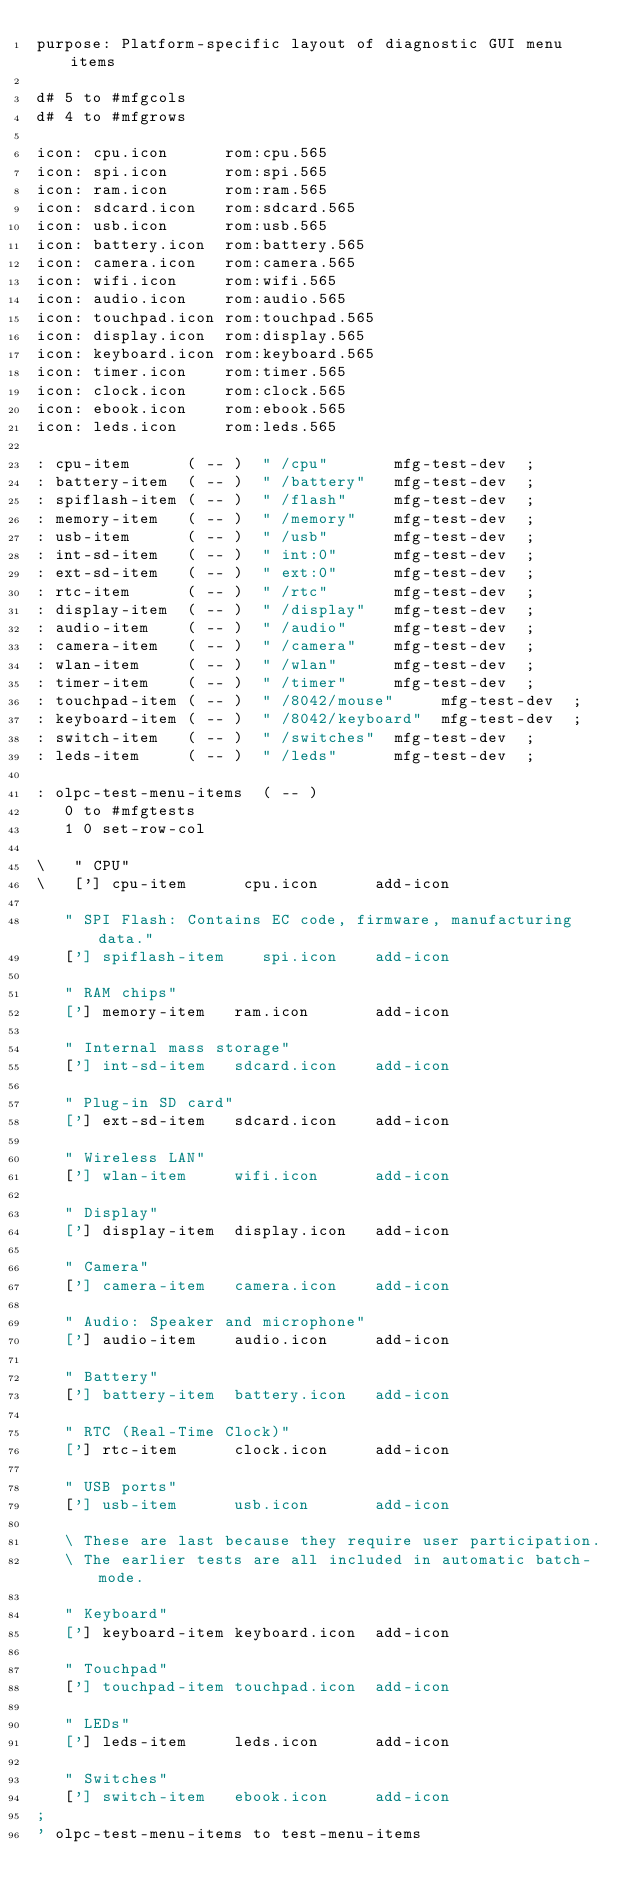<code> <loc_0><loc_0><loc_500><loc_500><_Forth_>purpose: Platform-specific layout of diagnostic GUI menu items

d# 5 to #mfgcols
d# 4 to #mfgrows

icon: cpu.icon      rom:cpu.565
icon: spi.icon      rom:spi.565
icon: ram.icon      rom:ram.565
icon: sdcard.icon   rom:sdcard.565
icon: usb.icon      rom:usb.565
icon: battery.icon  rom:battery.565
icon: camera.icon   rom:camera.565
icon: wifi.icon     rom:wifi.565
icon: audio.icon    rom:audio.565
icon: touchpad.icon rom:touchpad.565
icon: display.icon  rom:display.565
icon: keyboard.icon rom:keyboard.565
icon: timer.icon    rom:timer.565
icon: clock.icon    rom:clock.565
icon: ebook.icon    rom:ebook.565
icon: leds.icon     rom:leds.565

: cpu-item      ( -- )  " /cpu"       mfg-test-dev  ;
: battery-item  ( -- )  " /battery"   mfg-test-dev  ;
: spiflash-item ( -- )  " /flash"     mfg-test-dev  ;
: memory-item   ( -- )  " /memory"    mfg-test-dev  ;
: usb-item      ( -- )  " /usb"       mfg-test-dev  ;
: int-sd-item   ( -- )  " int:0"      mfg-test-dev  ;
: ext-sd-item   ( -- )  " ext:0"      mfg-test-dev  ;
: rtc-item      ( -- )  " /rtc"       mfg-test-dev  ;
: display-item  ( -- )  " /display"   mfg-test-dev  ;
: audio-item    ( -- )  " /audio"     mfg-test-dev  ;
: camera-item   ( -- )  " /camera"    mfg-test-dev  ;
: wlan-item     ( -- )  " /wlan"      mfg-test-dev  ;
: timer-item    ( -- )  " /timer"     mfg-test-dev  ;
: touchpad-item ( -- )  " /8042/mouse"     mfg-test-dev  ;
: keyboard-item ( -- )  " /8042/keyboard"  mfg-test-dev  ;
: switch-item   ( -- )  " /switches"  mfg-test-dev  ;
: leds-item     ( -- )  " /leds"      mfg-test-dev  ;

: olpc-test-menu-items  ( -- )
   0 to #mfgtests
   1 0 set-row-col

\   " CPU"
\   ['] cpu-item      cpu.icon      add-icon

   " SPI Flash: Contains EC code, firmware, manufacturing data."
   ['] spiflash-item    spi.icon    add-icon

   " RAM chips"
   ['] memory-item   ram.icon       add-icon

   " Internal mass storage"
   ['] int-sd-item   sdcard.icon    add-icon

   " Plug-in SD card"
   ['] ext-sd-item   sdcard.icon    add-icon

   " Wireless LAN"
   ['] wlan-item     wifi.icon      add-icon

   " Display"
   ['] display-item  display.icon   add-icon

   " Camera"
   ['] camera-item   camera.icon    add-icon

   " Audio: Speaker and microphone"
   ['] audio-item    audio.icon     add-icon

   " Battery"
   ['] battery-item  battery.icon   add-icon

   " RTC (Real-Time Clock)"
   ['] rtc-item      clock.icon     add-icon

   " USB ports"
   ['] usb-item      usb.icon       add-icon

   \ These are last because they require user participation.
   \ The earlier tests are all included in automatic batch-mode.

   " Keyboard"
   ['] keyboard-item keyboard.icon  add-icon

   " Touchpad"
   ['] touchpad-item touchpad.icon  add-icon

   " LEDs"
   ['] leds-item     leds.icon      add-icon

   " Switches"
   ['] switch-item   ebook.icon     add-icon
;
' olpc-test-menu-items to test-menu-items
</code> 